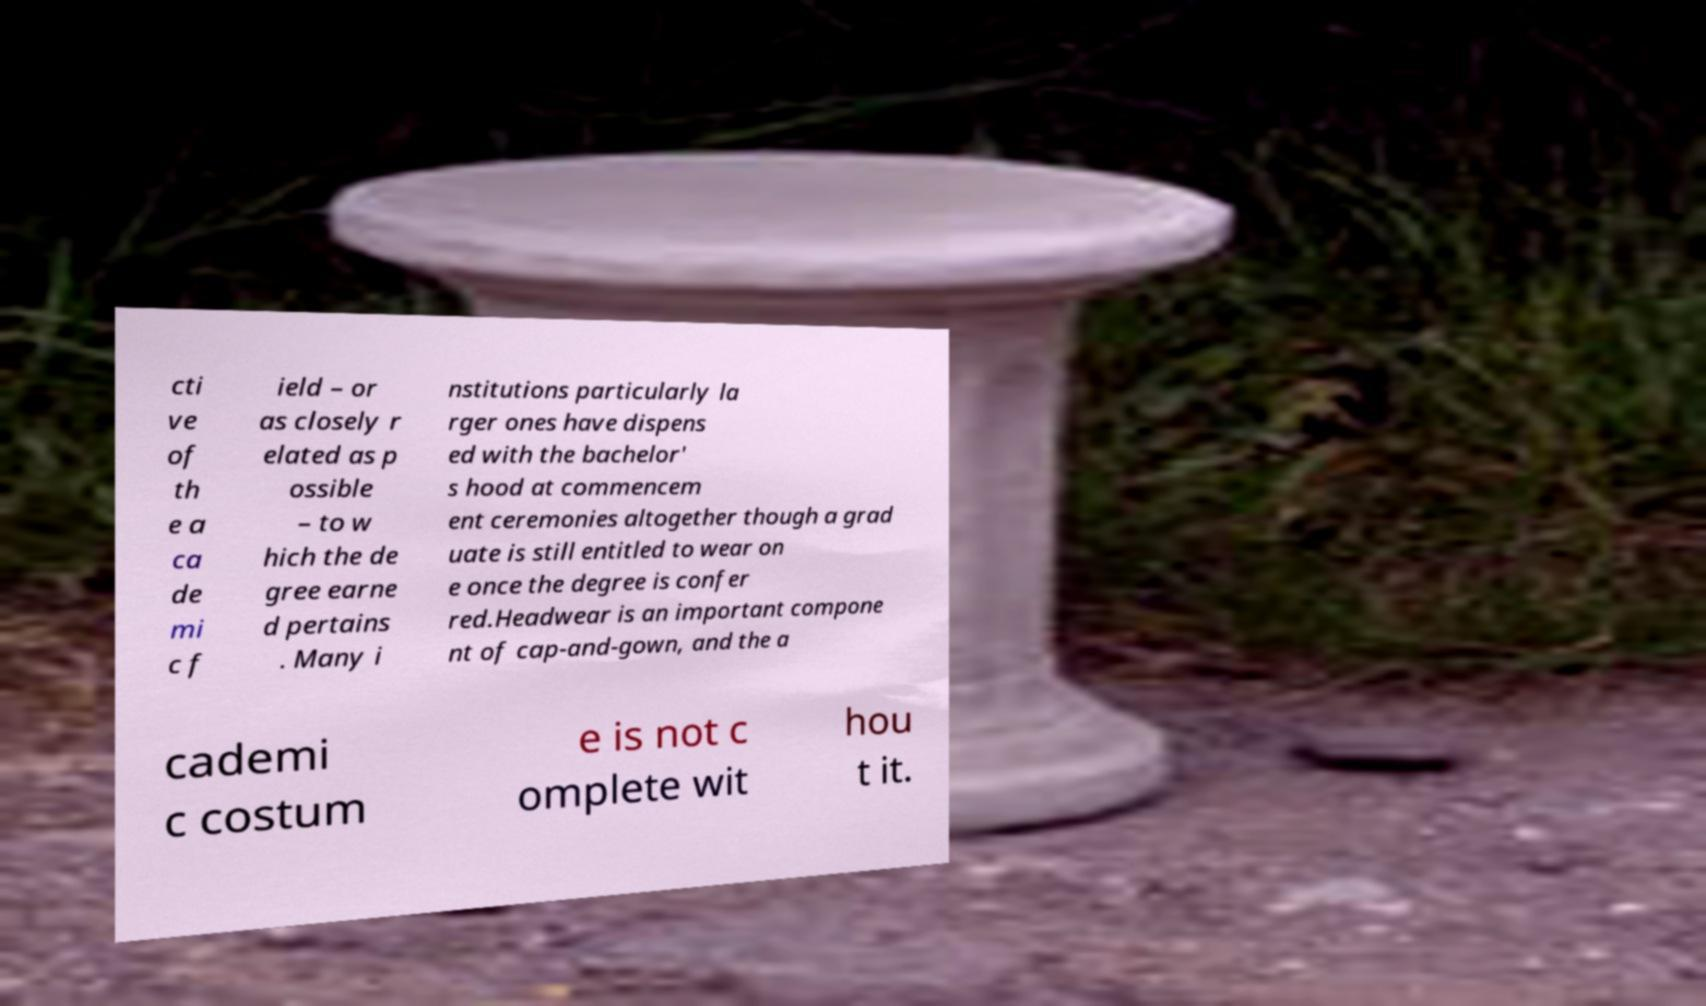Please identify and transcribe the text found in this image. cti ve of th e a ca de mi c f ield – or as closely r elated as p ossible – to w hich the de gree earne d pertains . Many i nstitutions particularly la rger ones have dispens ed with the bachelor' s hood at commencem ent ceremonies altogether though a grad uate is still entitled to wear on e once the degree is confer red.Headwear is an important compone nt of cap-and-gown, and the a cademi c costum e is not c omplete wit hou t it. 